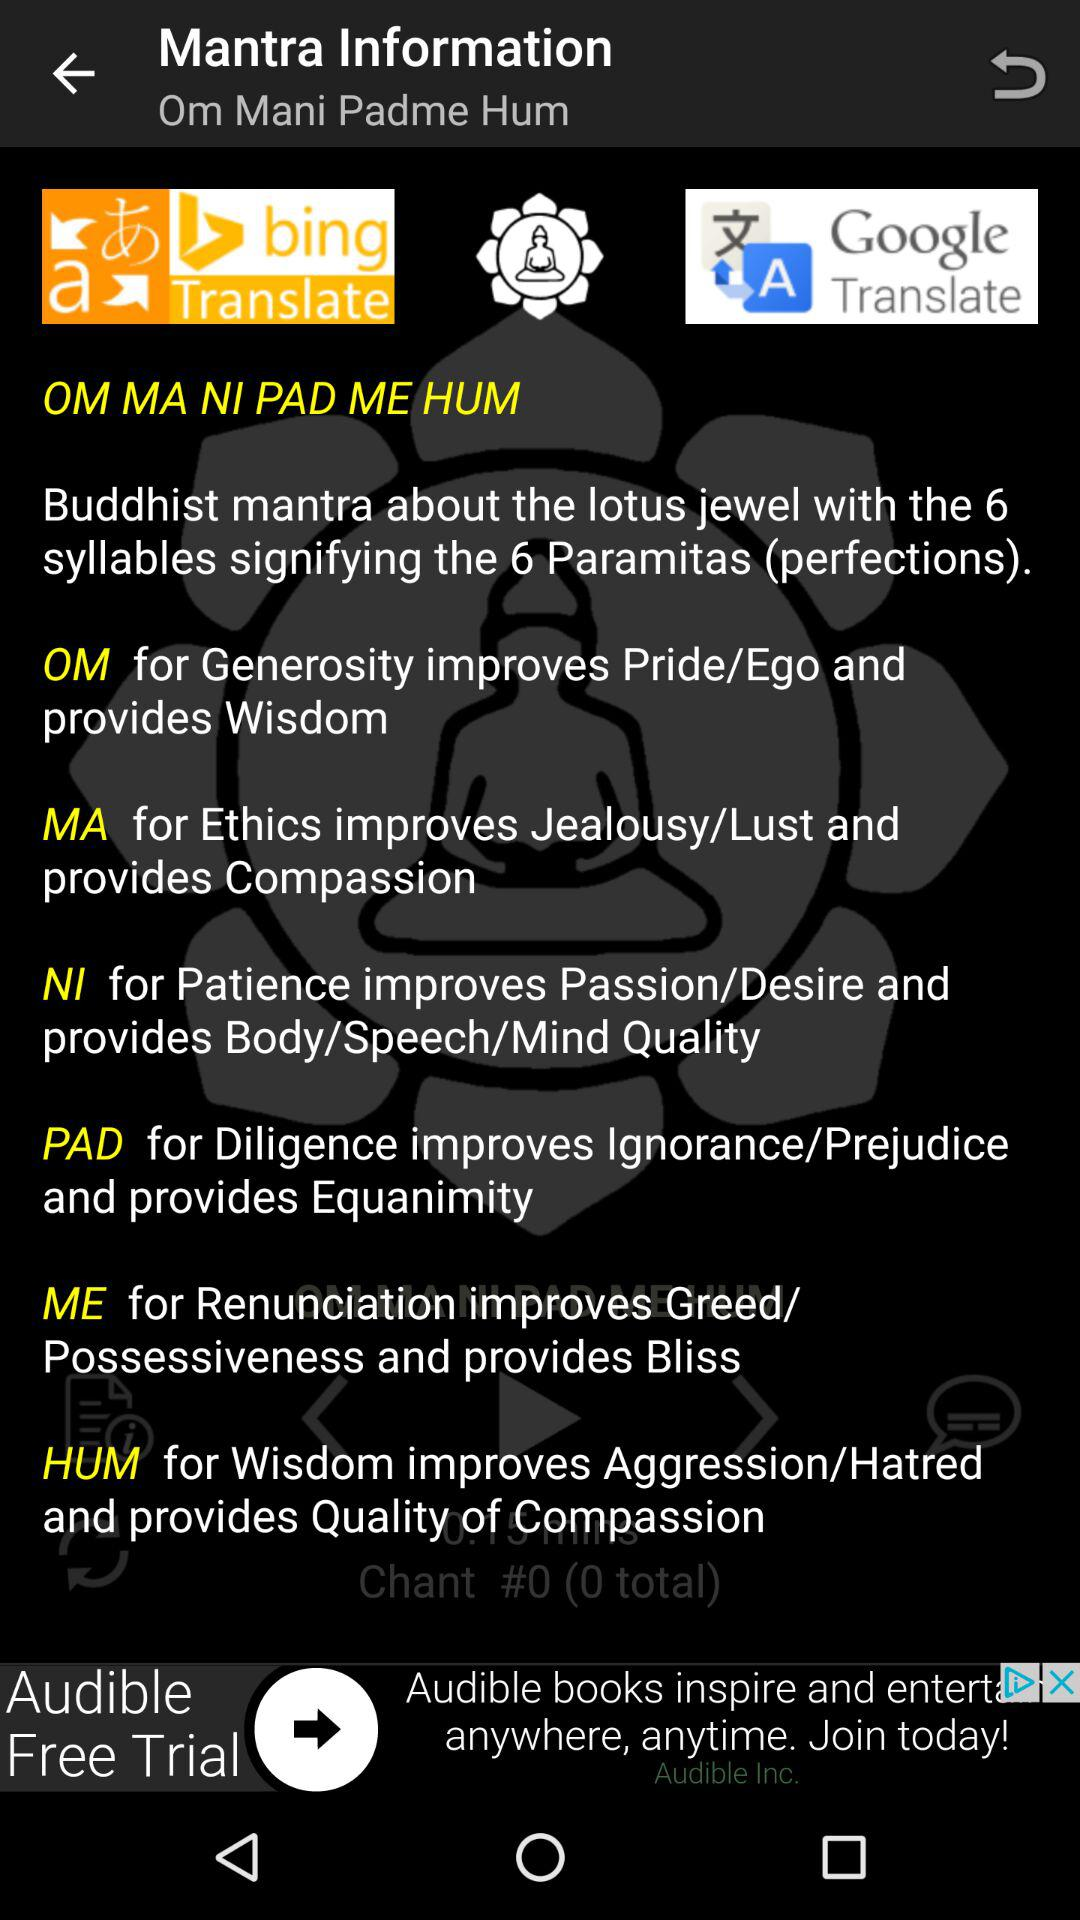What are the 6 syllables that signify the 6 paramitas (perfection)? The 6 syllables that signify the 6 paramitas are "OM", "MA", "NI", "PAD", "ME" and "HUM". 